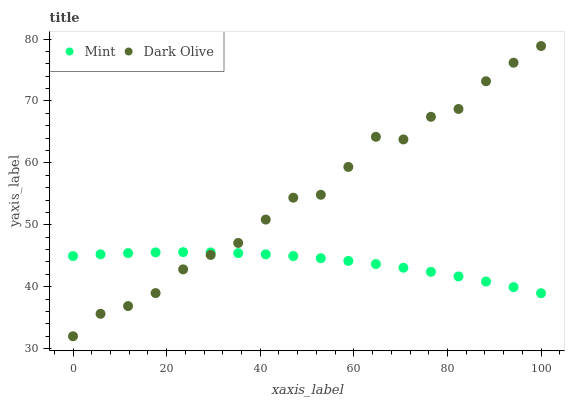Does Mint have the minimum area under the curve?
Answer yes or no. Yes. Does Dark Olive have the maximum area under the curve?
Answer yes or no. Yes. Does Mint have the maximum area under the curve?
Answer yes or no. No. Is Mint the smoothest?
Answer yes or no. Yes. Is Dark Olive the roughest?
Answer yes or no. Yes. Is Mint the roughest?
Answer yes or no. No. Does Dark Olive have the lowest value?
Answer yes or no. Yes. Does Mint have the lowest value?
Answer yes or no. No. Does Dark Olive have the highest value?
Answer yes or no. Yes. Does Mint have the highest value?
Answer yes or no. No. Does Dark Olive intersect Mint?
Answer yes or no. Yes. Is Dark Olive less than Mint?
Answer yes or no. No. Is Dark Olive greater than Mint?
Answer yes or no. No. 